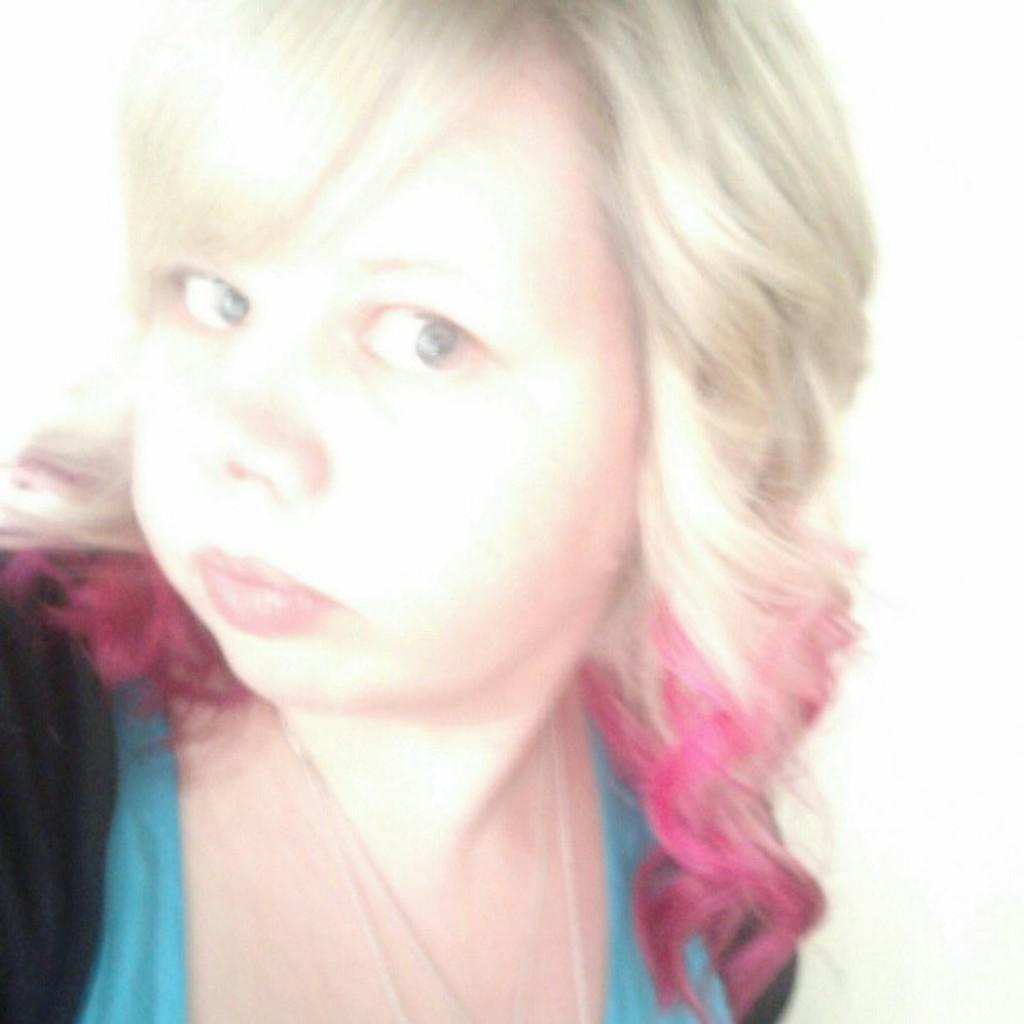Who is present in the image? There is a woman in the image. What can be seen behind the woman? The background of the image is white. What kind of trouble is the secretary experiencing in the image? There is no secretary present in the image, and therefore no trouble can be observed. 